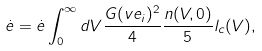<formula> <loc_0><loc_0><loc_500><loc_500>\dot { e } = \dot { e } \int _ { 0 } ^ { \infty } d V \frac { G ( v e _ { i } ) ^ { 2 } } { 4 } \frac { n ( V , 0 ) } { 5 } l _ { c } ( V ) ,</formula> 